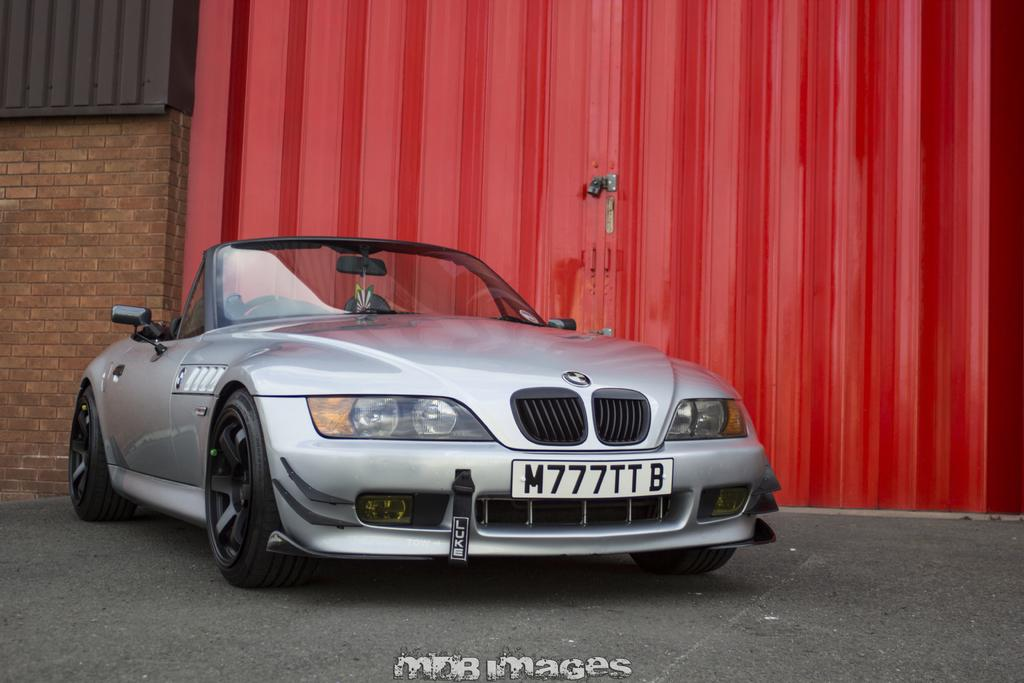What is located in front of the gate in the image? There is a car in front of the gate in the image. What can be seen on the left side of the image? There is a wall on the left side of the image. Is there any text present in the image? Yes, there is a text at the bottom of the image. How many children are playing in the shade in the image? There are no children or shade present in the image. What type of bed is visible in the image? There is no bed present in the image. 